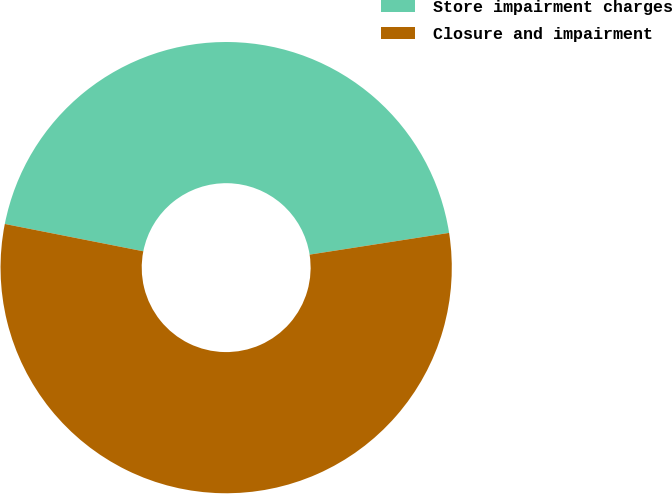Convert chart. <chart><loc_0><loc_0><loc_500><loc_500><pie_chart><fcel>Store impairment charges<fcel>Closure and impairment<nl><fcel>44.44%<fcel>55.56%<nl></chart> 